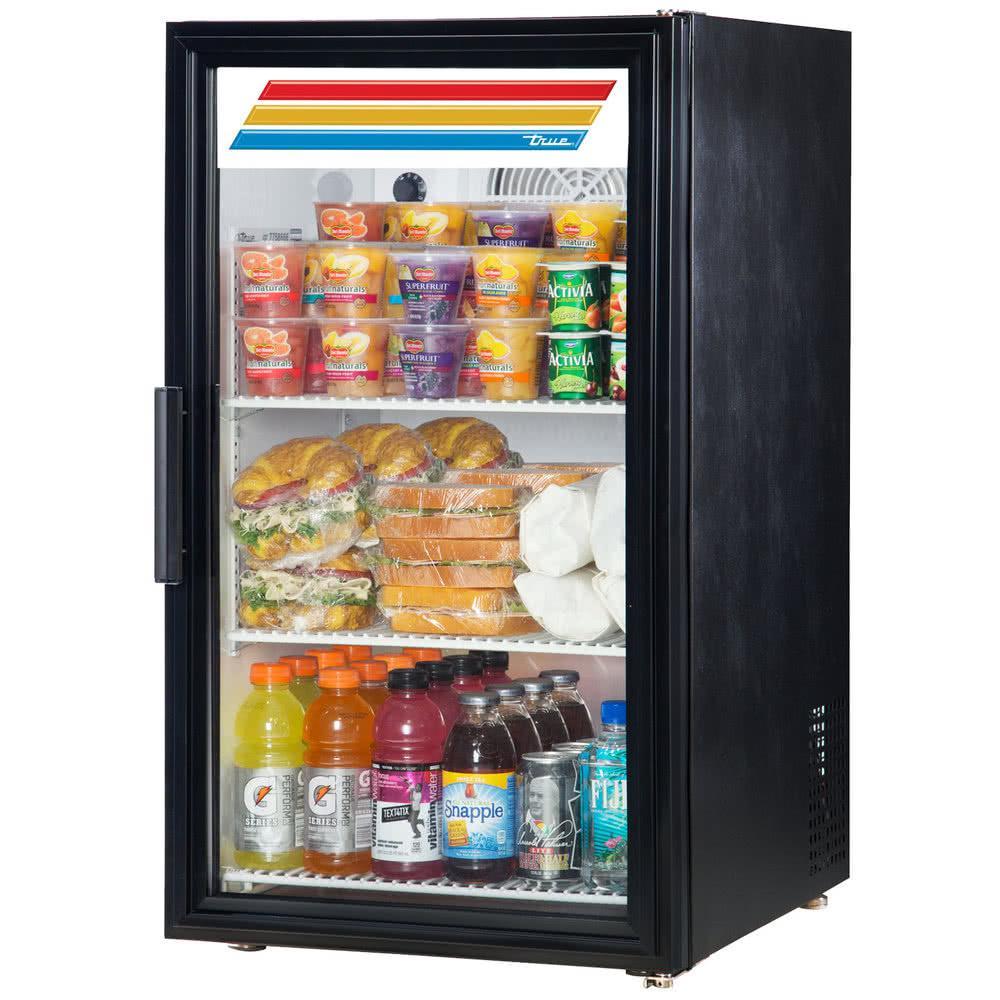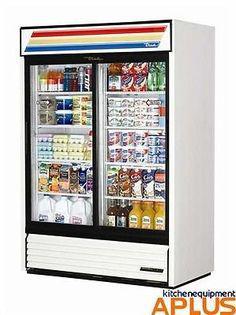The first image is the image on the left, the second image is the image on the right. Examine the images to the left and right. Is the description "The cooler display in the right image has three colored lines across the top that run nearly the width of the machine." accurate? Answer yes or no. Yes. 